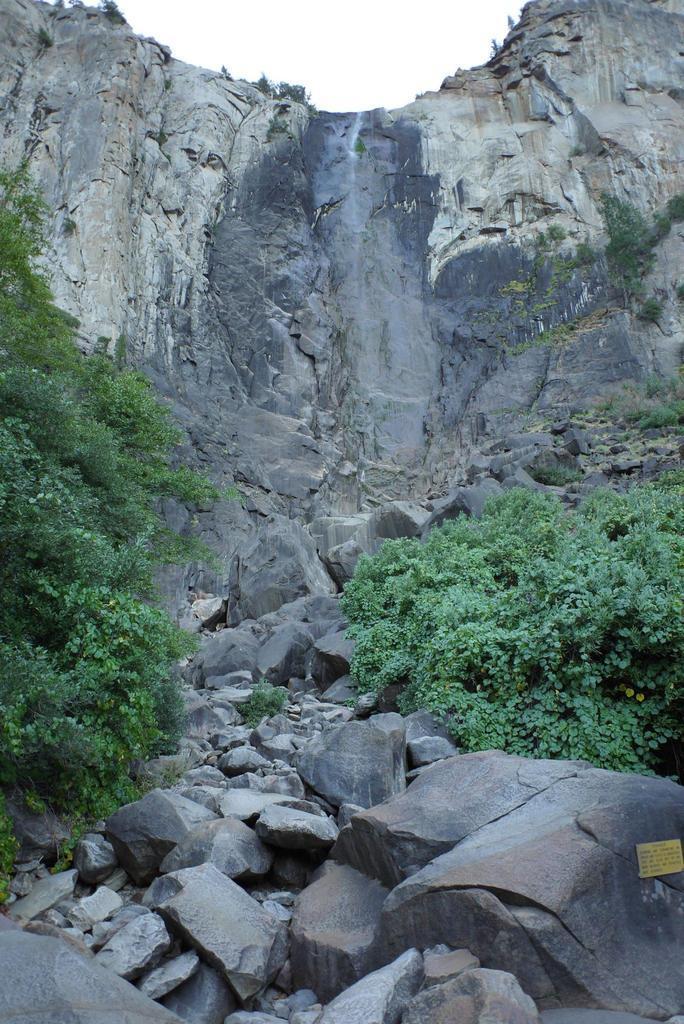Please provide a concise description of this image. This picture is clicked outside the city. In the foreground we can see the rocks and some plants. In the background there is the sky and we can see the mountain. 